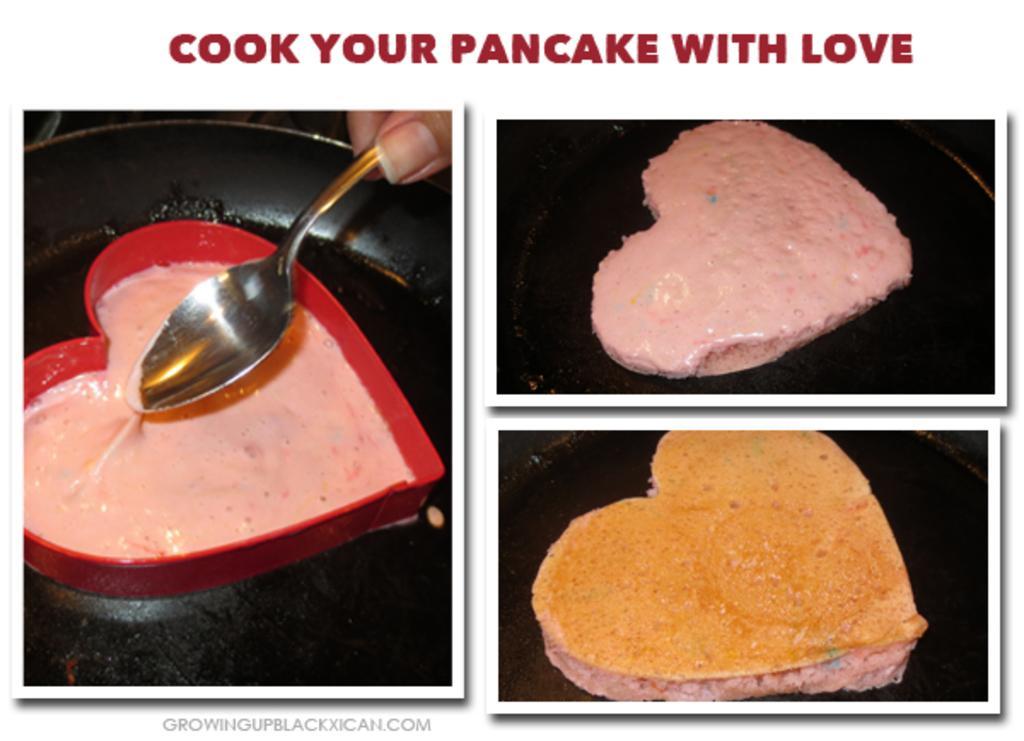Could you give a brief overview of what you see in this image? In this picture there is a collage of pancake. 